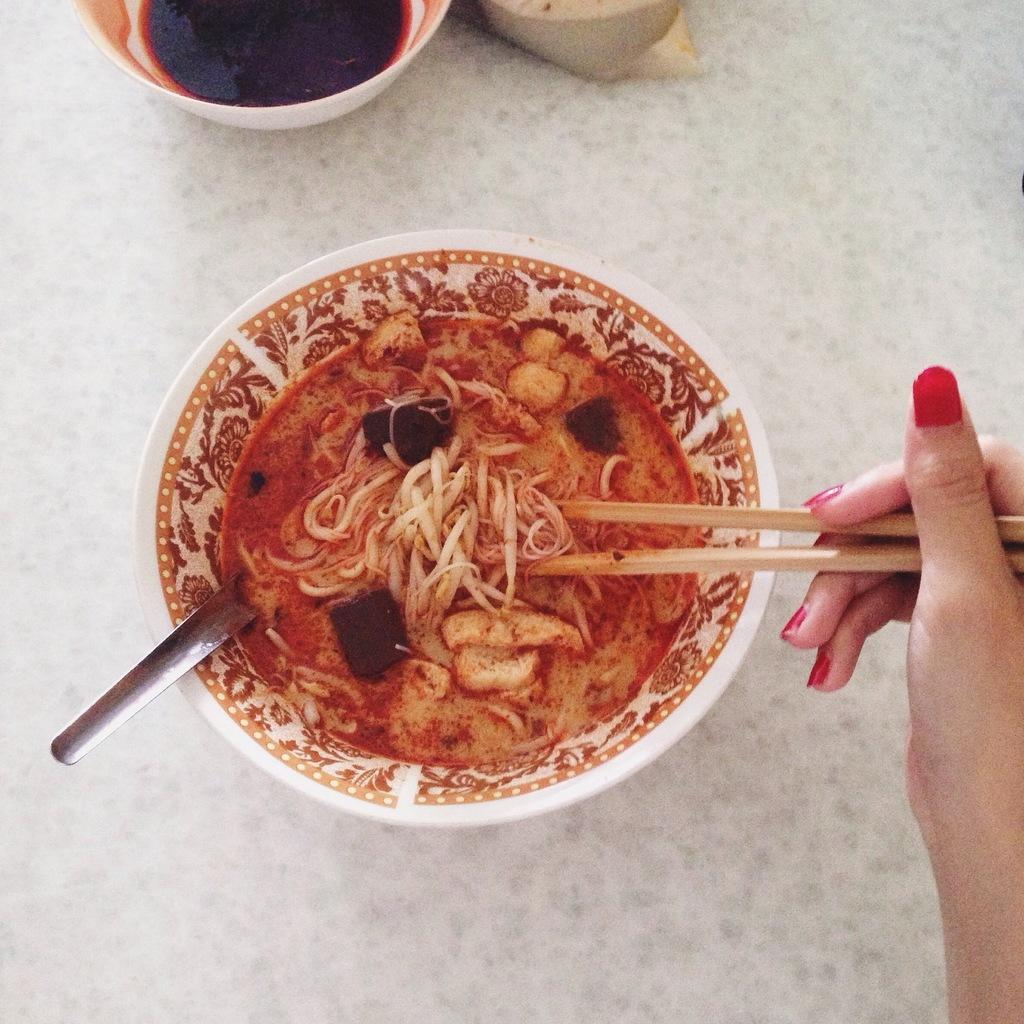What type of dishware can be seen in the image? There are bowls in the image. What utensils are present in the image? There are spoons in the image. What is being served or eaten in the image? There is food in the image. What are the people holding in their hands in the image? There are sticks being held in hand in the image. What type of shoes can be seen in the image? There are no shoes visible in the image. What type of plastic items can be seen in the image? There is no information about plastic items in the image. 